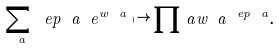<formula> <loc_0><loc_0><loc_500><loc_500>\sum _ { \ a } \ e p _ { \ } a \ e ^ { w _ { \ } a } \mapsto \prod _ { \ } a { w _ { \ } a } ^ { \ e p _ { \ } a } .</formula> 